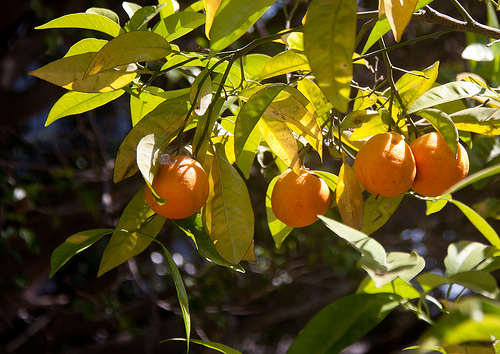<image>
Is the orange under the leaf? Yes. The orange is positioned underneath the leaf, with the leaf above it in the vertical space. 